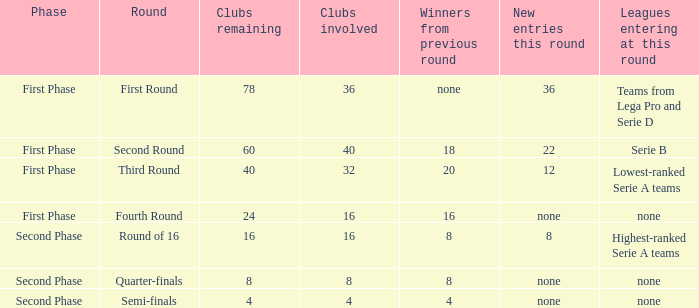The latest additions this cycle were displayed as 12, in which stage would you locate this? First Phase. 